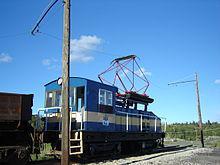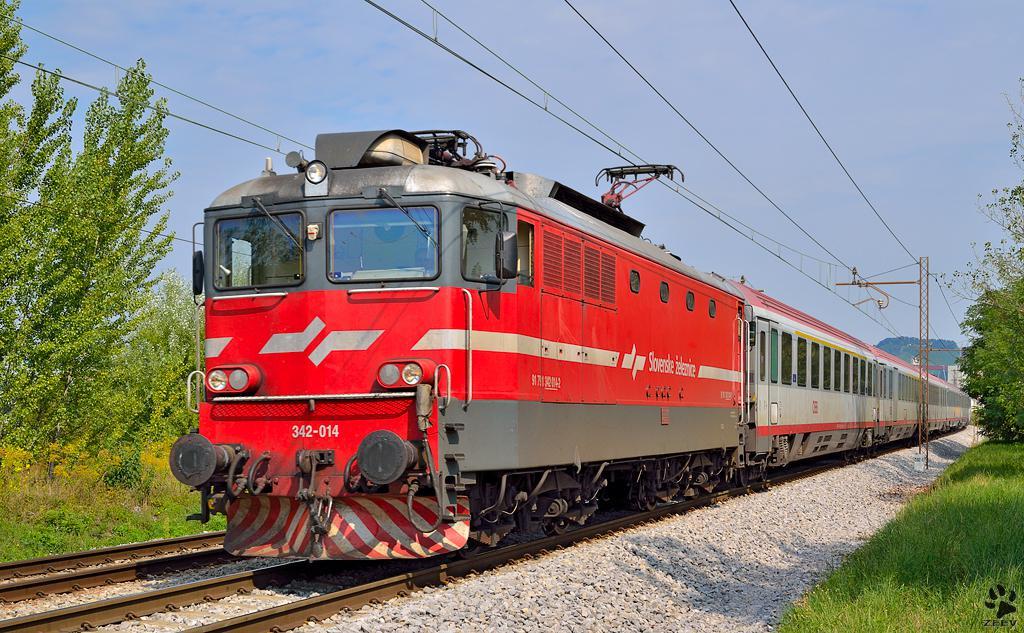The first image is the image on the left, the second image is the image on the right. Considering the images on both sides, is "The train in on the track in the image on the right is primarily yellow." valid? Answer yes or no. No. The first image is the image on the left, the second image is the image on the right. Analyze the images presented: Is the assertion "Both images show a train with at least one train car, and both trains are headed in the same direction and will not collide." valid? Answer yes or no. No. 